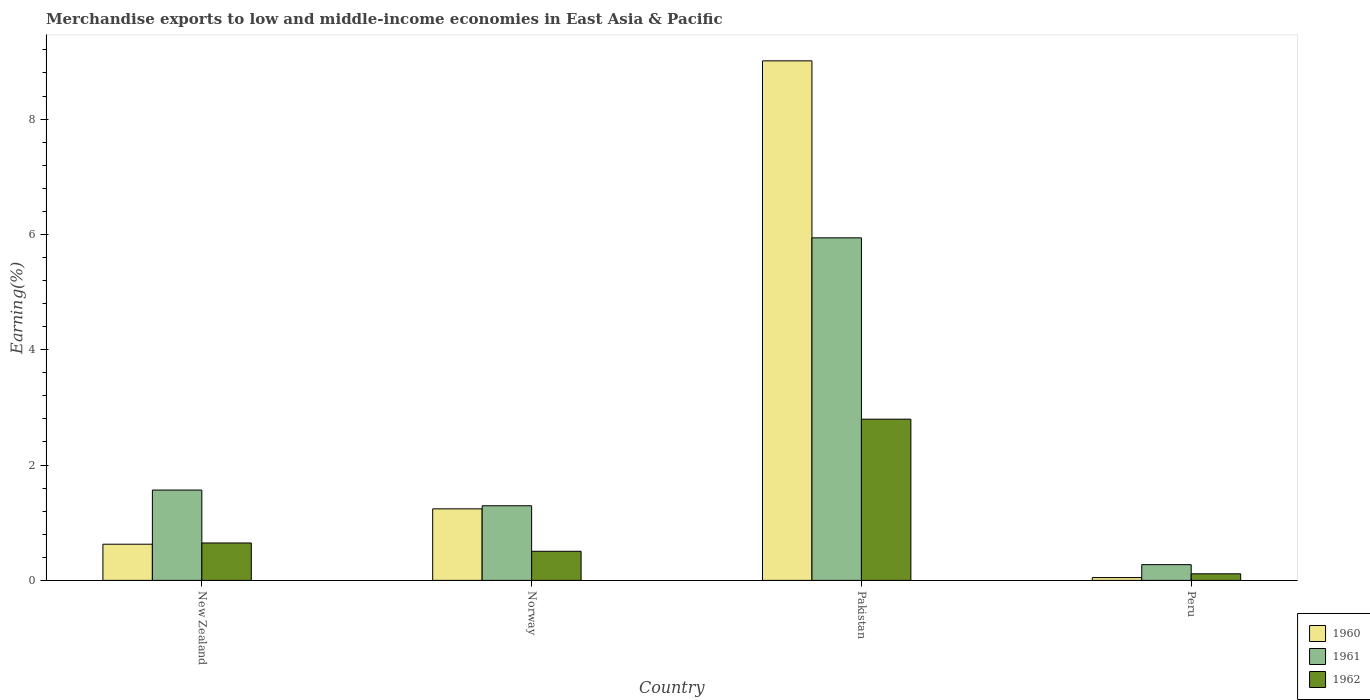How many groups of bars are there?
Offer a terse response. 4. Are the number of bars per tick equal to the number of legend labels?
Ensure brevity in your answer.  Yes. Are the number of bars on each tick of the X-axis equal?
Your answer should be very brief. Yes. What is the percentage of amount earned from merchandise exports in 1961 in Pakistan?
Your answer should be compact. 5.94. Across all countries, what is the maximum percentage of amount earned from merchandise exports in 1960?
Ensure brevity in your answer.  9.01. Across all countries, what is the minimum percentage of amount earned from merchandise exports in 1961?
Give a very brief answer. 0.27. In which country was the percentage of amount earned from merchandise exports in 1962 maximum?
Ensure brevity in your answer.  Pakistan. What is the total percentage of amount earned from merchandise exports in 1962 in the graph?
Give a very brief answer. 4.06. What is the difference between the percentage of amount earned from merchandise exports in 1960 in New Zealand and that in Peru?
Make the answer very short. 0.58. What is the difference between the percentage of amount earned from merchandise exports in 1960 in Peru and the percentage of amount earned from merchandise exports in 1962 in New Zealand?
Your answer should be very brief. -0.6. What is the average percentage of amount earned from merchandise exports in 1962 per country?
Provide a short and direct response. 1.02. What is the difference between the percentage of amount earned from merchandise exports of/in 1961 and percentage of amount earned from merchandise exports of/in 1962 in New Zealand?
Ensure brevity in your answer.  0.92. What is the ratio of the percentage of amount earned from merchandise exports in 1961 in Norway to that in Peru?
Your answer should be very brief. 4.74. Is the percentage of amount earned from merchandise exports in 1962 in New Zealand less than that in Norway?
Your answer should be very brief. No. Is the difference between the percentage of amount earned from merchandise exports in 1961 in New Zealand and Peru greater than the difference between the percentage of amount earned from merchandise exports in 1962 in New Zealand and Peru?
Offer a very short reply. Yes. What is the difference between the highest and the second highest percentage of amount earned from merchandise exports in 1962?
Make the answer very short. 0.14. What is the difference between the highest and the lowest percentage of amount earned from merchandise exports in 1962?
Give a very brief answer. 2.68. Is it the case that in every country, the sum of the percentage of amount earned from merchandise exports in 1961 and percentage of amount earned from merchandise exports in 1960 is greater than the percentage of amount earned from merchandise exports in 1962?
Your answer should be compact. Yes. How many countries are there in the graph?
Your response must be concise. 4. Does the graph contain any zero values?
Ensure brevity in your answer.  No. Does the graph contain grids?
Keep it short and to the point. No. How many legend labels are there?
Provide a short and direct response. 3. What is the title of the graph?
Your response must be concise. Merchandise exports to low and middle-income economies in East Asia & Pacific. Does "1988" appear as one of the legend labels in the graph?
Provide a succinct answer. No. What is the label or title of the Y-axis?
Your answer should be very brief. Earning(%). What is the Earning(%) of 1960 in New Zealand?
Provide a short and direct response. 0.63. What is the Earning(%) of 1961 in New Zealand?
Offer a very short reply. 1.57. What is the Earning(%) of 1962 in New Zealand?
Give a very brief answer. 0.65. What is the Earning(%) of 1960 in Norway?
Ensure brevity in your answer.  1.24. What is the Earning(%) of 1961 in Norway?
Your response must be concise. 1.29. What is the Earning(%) of 1962 in Norway?
Offer a terse response. 0.5. What is the Earning(%) in 1960 in Pakistan?
Your answer should be compact. 9.01. What is the Earning(%) in 1961 in Pakistan?
Give a very brief answer. 5.94. What is the Earning(%) in 1962 in Pakistan?
Keep it short and to the point. 2.8. What is the Earning(%) in 1960 in Peru?
Offer a very short reply. 0.05. What is the Earning(%) of 1961 in Peru?
Your answer should be very brief. 0.27. What is the Earning(%) in 1962 in Peru?
Make the answer very short. 0.11. Across all countries, what is the maximum Earning(%) in 1960?
Keep it short and to the point. 9.01. Across all countries, what is the maximum Earning(%) of 1961?
Keep it short and to the point. 5.94. Across all countries, what is the maximum Earning(%) in 1962?
Offer a terse response. 2.8. Across all countries, what is the minimum Earning(%) in 1960?
Provide a short and direct response. 0.05. Across all countries, what is the minimum Earning(%) in 1961?
Provide a succinct answer. 0.27. Across all countries, what is the minimum Earning(%) in 1962?
Make the answer very short. 0.11. What is the total Earning(%) of 1960 in the graph?
Ensure brevity in your answer.  10.93. What is the total Earning(%) of 1961 in the graph?
Ensure brevity in your answer.  9.07. What is the total Earning(%) in 1962 in the graph?
Offer a terse response. 4.06. What is the difference between the Earning(%) in 1960 in New Zealand and that in Norway?
Offer a terse response. -0.61. What is the difference between the Earning(%) in 1961 in New Zealand and that in Norway?
Provide a succinct answer. 0.27. What is the difference between the Earning(%) of 1962 in New Zealand and that in Norway?
Your answer should be compact. 0.14. What is the difference between the Earning(%) of 1960 in New Zealand and that in Pakistan?
Offer a very short reply. -8.38. What is the difference between the Earning(%) of 1961 in New Zealand and that in Pakistan?
Give a very brief answer. -4.37. What is the difference between the Earning(%) in 1962 in New Zealand and that in Pakistan?
Provide a short and direct response. -2.15. What is the difference between the Earning(%) of 1960 in New Zealand and that in Peru?
Your answer should be compact. 0.58. What is the difference between the Earning(%) of 1961 in New Zealand and that in Peru?
Your answer should be compact. 1.29. What is the difference between the Earning(%) of 1962 in New Zealand and that in Peru?
Ensure brevity in your answer.  0.53. What is the difference between the Earning(%) of 1960 in Norway and that in Pakistan?
Your answer should be very brief. -7.77. What is the difference between the Earning(%) of 1961 in Norway and that in Pakistan?
Provide a short and direct response. -4.65. What is the difference between the Earning(%) in 1962 in Norway and that in Pakistan?
Offer a very short reply. -2.29. What is the difference between the Earning(%) of 1960 in Norway and that in Peru?
Your answer should be very brief. 1.19. What is the difference between the Earning(%) in 1961 in Norway and that in Peru?
Keep it short and to the point. 1.02. What is the difference between the Earning(%) of 1962 in Norway and that in Peru?
Keep it short and to the point. 0.39. What is the difference between the Earning(%) of 1960 in Pakistan and that in Peru?
Provide a short and direct response. 8.96. What is the difference between the Earning(%) in 1961 in Pakistan and that in Peru?
Provide a succinct answer. 5.67. What is the difference between the Earning(%) in 1962 in Pakistan and that in Peru?
Offer a very short reply. 2.68. What is the difference between the Earning(%) of 1960 in New Zealand and the Earning(%) of 1961 in Norway?
Your answer should be compact. -0.67. What is the difference between the Earning(%) of 1960 in New Zealand and the Earning(%) of 1962 in Norway?
Provide a succinct answer. 0.12. What is the difference between the Earning(%) of 1961 in New Zealand and the Earning(%) of 1962 in Norway?
Your answer should be compact. 1.06. What is the difference between the Earning(%) of 1960 in New Zealand and the Earning(%) of 1961 in Pakistan?
Your response must be concise. -5.31. What is the difference between the Earning(%) in 1960 in New Zealand and the Earning(%) in 1962 in Pakistan?
Provide a succinct answer. -2.17. What is the difference between the Earning(%) in 1961 in New Zealand and the Earning(%) in 1962 in Pakistan?
Your answer should be very brief. -1.23. What is the difference between the Earning(%) in 1960 in New Zealand and the Earning(%) in 1961 in Peru?
Ensure brevity in your answer.  0.35. What is the difference between the Earning(%) in 1960 in New Zealand and the Earning(%) in 1962 in Peru?
Provide a succinct answer. 0.51. What is the difference between the Earning(%) in 1961 in New Zealand and the Earning(%) in 1962 in Peru?
Your answer should be compact. 1.45. What is the difference between the Earning(%) in 1960 in Norway and the Earning(%) in 1961 in Pakistan?
Your answer should be very brief. -4.7. What is the difference between the Earning(%) in 1960 in Norway and the Earning(%) in 1962 in Pakistan?
Provide a short and direct response. -1.56. What is the difference between the Earning(%) of 1961 in Norway and the Earning(%) of 1962 in Pakistan?
Keep it short and to the point. -1.5. What is the difference between the Earning(%) of 1960 in Norway and the Earning(%) of 1961 in Peru?
Make the answer very short. 0.97. What is the difference between the Earning(%) of 1960 in Norway and the Earning(%) of 1962 in Peru?
Your answer should be compact. 1.13. What is the difference between the Earning(%) in 1961 in Norway and the Earning(%) in 1962 in Peru?
Give a very brief answer. 1.18. What is the difference between the Earning(%) of 1960 in Pakistan and the Earning(%) of 1961 in Peru?
Ensure brevity in your answer.  8.74. What is the difference between the Earning(%) of 1960 in Pakistan and the Earning(%) of 1962 in Peru?
Make the answer very short. 8.9. What is the difference between the Earning(%) in 1961 in Pakistan and the Earning(%) in 1962 in Peru?
Give a very brief answer. 5.83. What is the average Earning(%) in 1960 per country?
Make the answer very short. 2.73. What is the average Earning(%) of 1961 per country?
Make the answer very short. 2.27. What is the average Earning(%) of 1962 per country?
Offer a very short reply. 1.02. What is the difference between the Earning(%) of 1960 and Earning(%) of 1961 in New Zealand?
Provide a short and direct response. -0.94. What is the difference between the Earning(%) of 1960 and Earning(%) of 1962 in New Zealand?
Provide a succinct answer. -0.02. What is the difference between the Earning(%) of 1961 and Earning(%) of 1962 in New Zealand?
Give a very brief answer. 0.92. What is the difference between the Earning(%) of 1960 and Earning(%) of 1961 in Norway?
Make the answer very short. -0.05. What is the difference between the Earning(%) in 1960 and Earning(%) in 1962 in Norway?
Make the answer very short. 0.74. What is the difference between the Earning(%) in 1961 and Earning(%) in 1962 in Norway?
Your answer should be compact. 0.79. What is the difference between the Earning(%) of 1960 and Earning(%) of 1961 in Pakistan?
Provide a short and direct response. 3.07. What is the difference between the Earning(%) of 1960 and Earning(%) of 1962 in Pakistan?
Offer a terse response. 6.21. What is the difference between the Earning(%) in 1961 and Earning(%) in 1962 in Pakistan?
Your answer should be very brief. 3.14. What is the difference between the Earning(%) of 1960 and Earning(%) of 1961 in Peru?
Provide a short and direct response. -0.22. What is the difference between the Earning(%) in 1960 and Earning(%) in 1962 in Peru?
Keep it short and to the point. -0.07. What is the difference between the Earning(%) in 1961 and Earning(%) in 1962 in Peru?
Your answer should be very brief. 0.16. What is the ratio of the Earning(%) of 1960 in New Zealand to that in Norway?
Provide a succinct answer. 0.51. What is the ratio of the Earning(%) of 1961 in New Zealand to that in Norway?
Your answer should be compact. 1.21. What is the ratio of the Earning(%) of 1962 in New Zealand to that in Norway?
Offer a terse response. 1.29. What is the ratio of the Earning(%) in 1960 in New Zealand to that in Pakistan?
Your answer should be compact. 0.07. What is the ratio of the Earning(%) of 1961 in New Zealand to that in Pakistan?
Your answer should be very brief. 0.26. What is the ratio of the Earning(%) of 1962 in New Zealand to that in Pakistan?
Make the answer very short. 0.23. What is the ratio of the Earning(%) in 1960 in New Zealand to that in Peru?
Ensure brevity in your answer.  12.82. What is the ratio of the Earning(%) of 1961 in New Zealand to that in Peru?
Your response must be concise. 5.74. What is the ratio of the Earning(%) in 1962 in New Zealand to that in Peru?
Offer a very short reply. 5.69. What is the ratio of the Earning(%) in 1960 in Norway to that in Pakistan?
Give a very brief answer. 0.14. What is the ratio of the Earning(%) in 1961 in Norway to that in Pakistan?
Offer a terse response. 0.22. What is the ratio of the Earning(%) in 1962 in Norway to that in Pakistan?
Provide a short and direct response. 0.18. What is the ratio of the Earning(%) of 1960 in Norway to that in Peru?
Provide a succinct answer. 25.36. What is the ratio of the Earning(%) in 1961 in Norway to that in Peru?
Provide a short and direct response. 4.74. What is the ratio of the Earning(%) of 1962 in Norway to that in Peru?
Your answer should be very brief. 4.42. What is the ratio of the Earning(%) of 1960 in Pakistan to that in Peru?
Keep it short and to the point. 184.16. What is the ratio of the Earning(%) in 1961 in Pakistan to that in Peru?
Ensure brevity in your answer.  21.77. What is the ratio of the Earning(%) in 1962 in Pakistan to that in Peru?
Your response must be concise. 24.5. What is the difference between the highest and the second highest Earning(%) of 1960?
Your answer should be very brief. 7.77. What is the difference between the highest and the second highest Earning(%) of 1961?
Offer a very short reply. 4.37. What is the difference between the highest and the second highest Earning(%) in 1962?
Offer a very short reply. 2.15. What is the difference between the highest and the lowest Earning(%) in 1960?
Make the answer very short. 8.96. What is the difference between the highest and the lowest Earning(%) in 1961?
Your answer should be compact. 5.67. What is the difference between the highest and the lowest Earning(%) of 1962?
Ensure brevity in your answer.  2.68. 